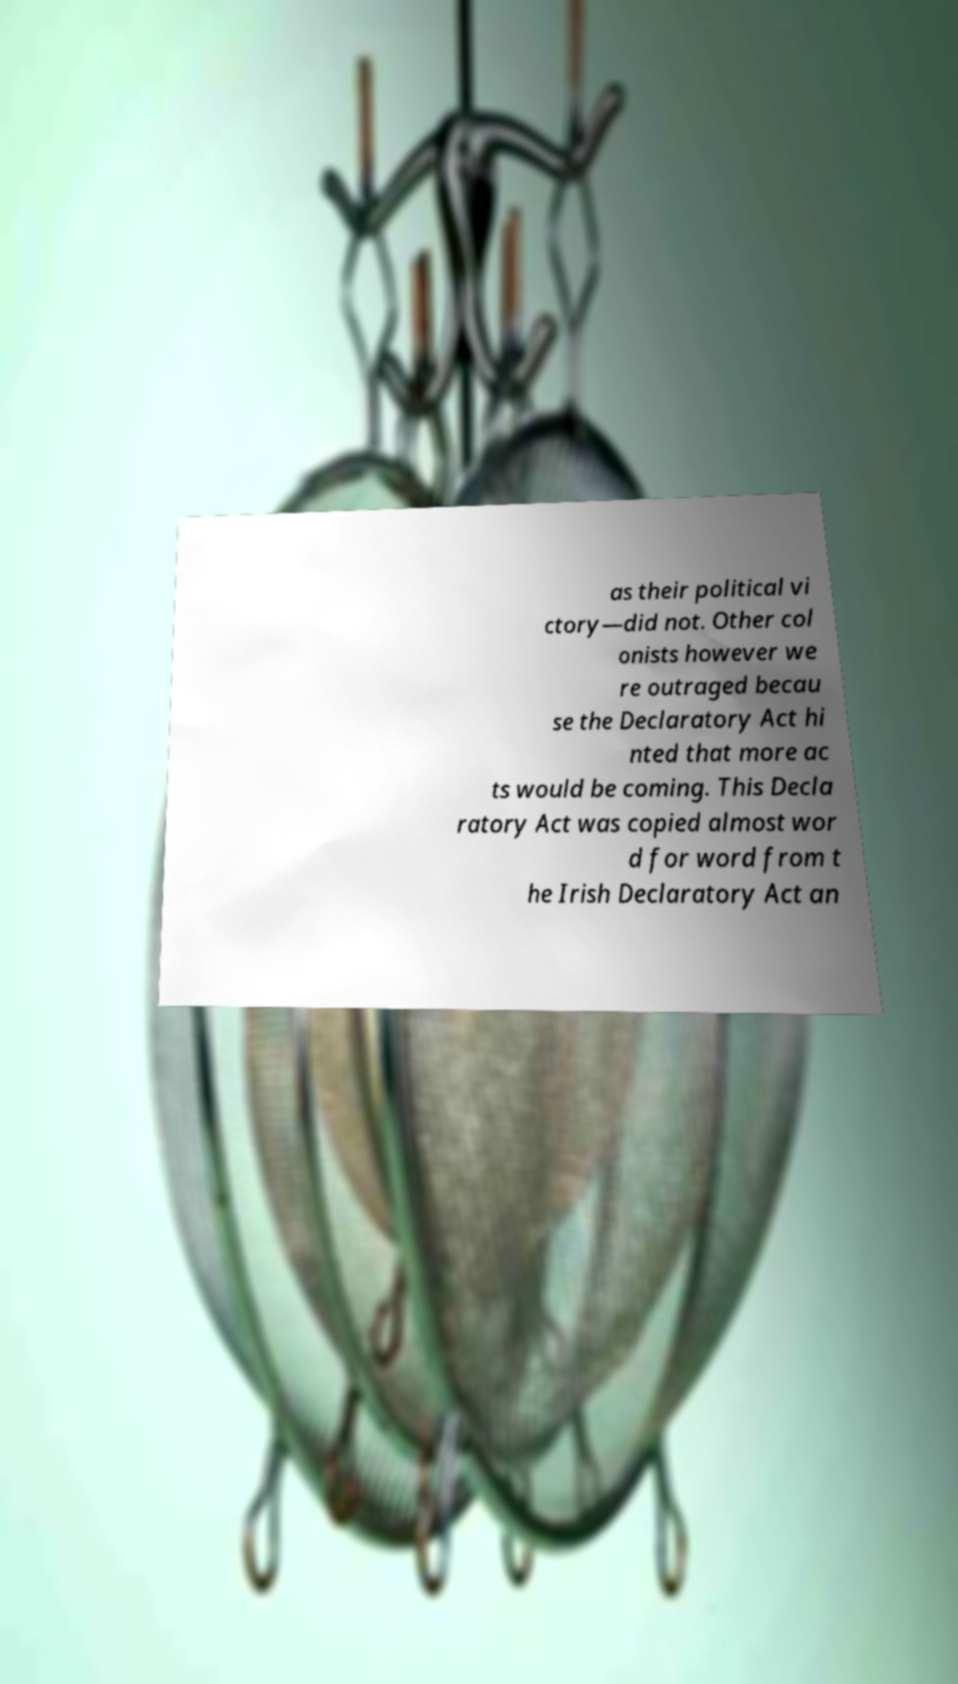Could you extract and type out the text from this image? as their political vi ctory—did not. Other col onists however we re outraged becau se the Declaratory Act hi nted that more ac ts would be coming. This Decla ratory Act was copied almost wor d for word from t he Irish Declaratory Act an 